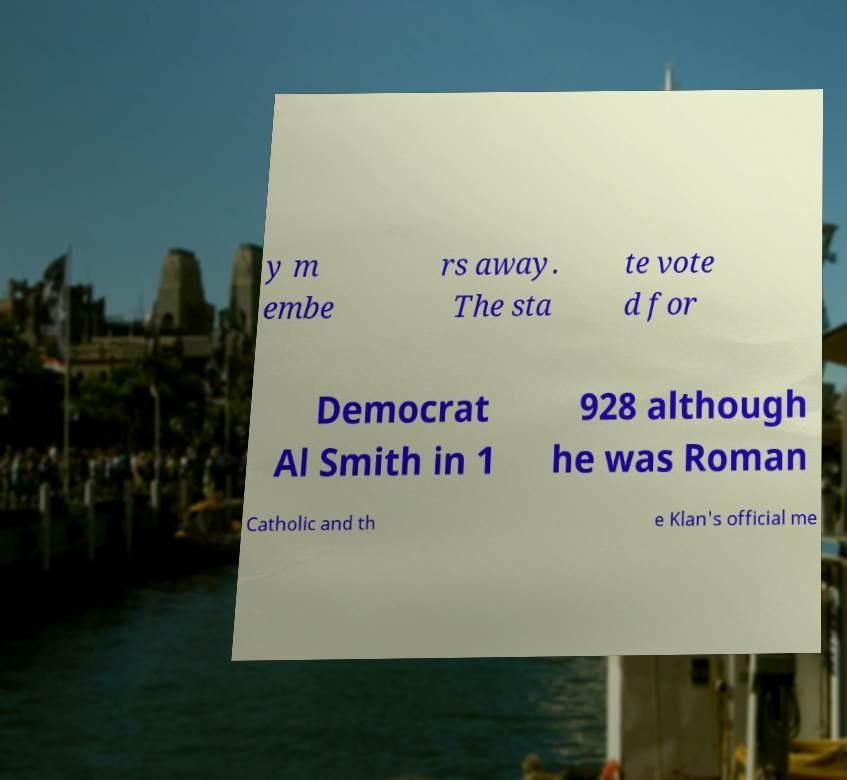Can you accurately transcribe the text from the provided image for me? y m embe rs away. The sta te vote d for Democrat Al Smith in 1 928 although he was Roman Catholic and th e Klan's official me 